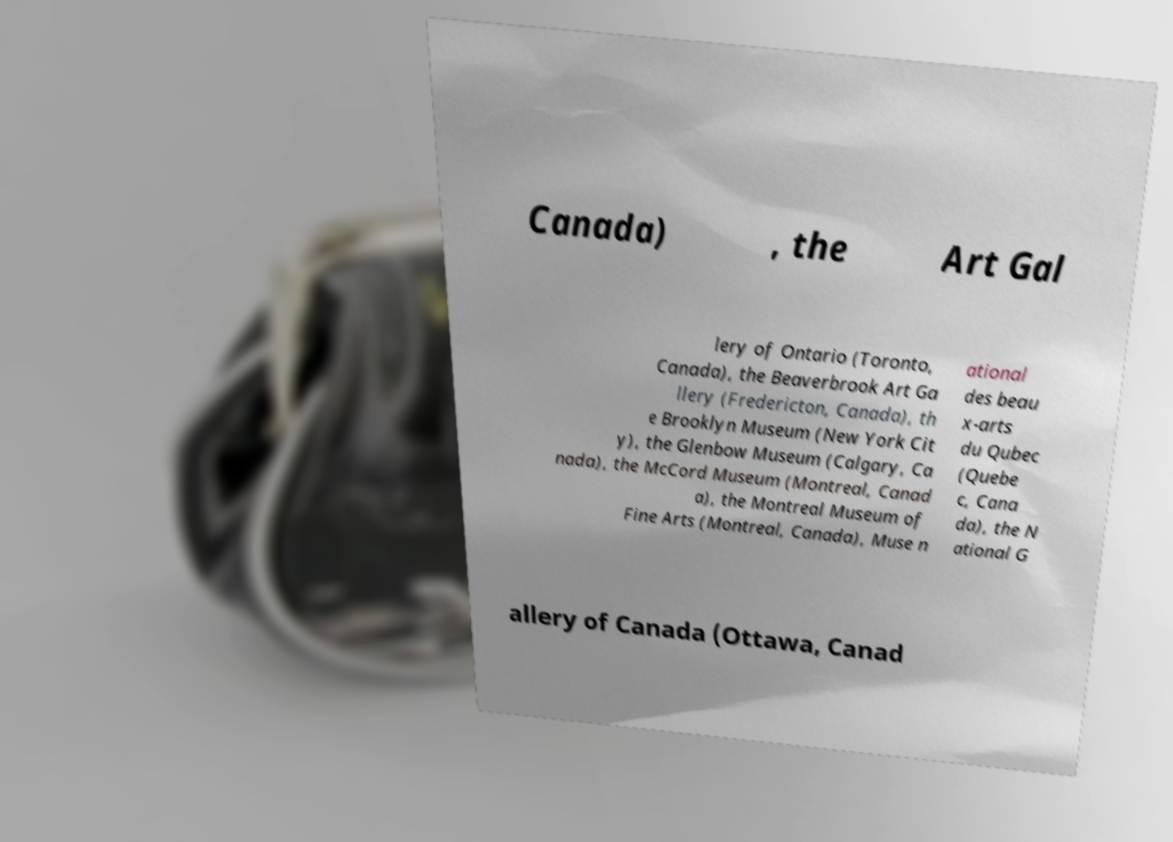Can you read and provide the text displayed in the image?This photo seems to have some interesting text. Can you extract and type it out for me? Canada) , the Art Gal lery of Ontario (Toronto, Canada), the Beaverbrook Art Ga llery (Fredericton, Canada), th e Brooklyn Museum (New York Cit y), the Glenbow Museum (Calgary, Ca nada), the McCord Museum (Montreal, Canad a), the Montreal Museum of Fine Arts (Montreal, Canada), Muse n ational des beau x-arts du Qubec (Quebe c, Cana da), the N ational G allery of Canada (Ottawa, Canad 